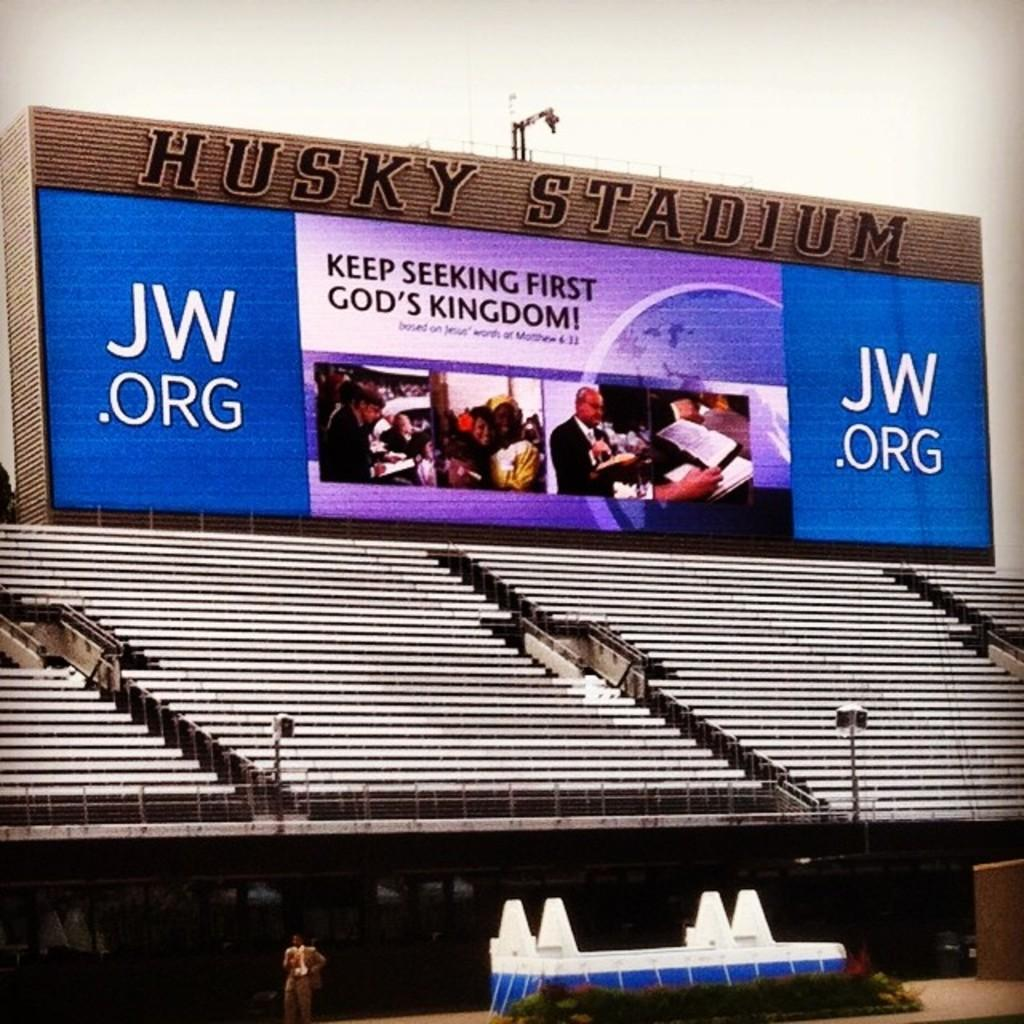<image>
Provide a brief description of the given image. A large empty stadium with the title Husky Stadium at the top. 